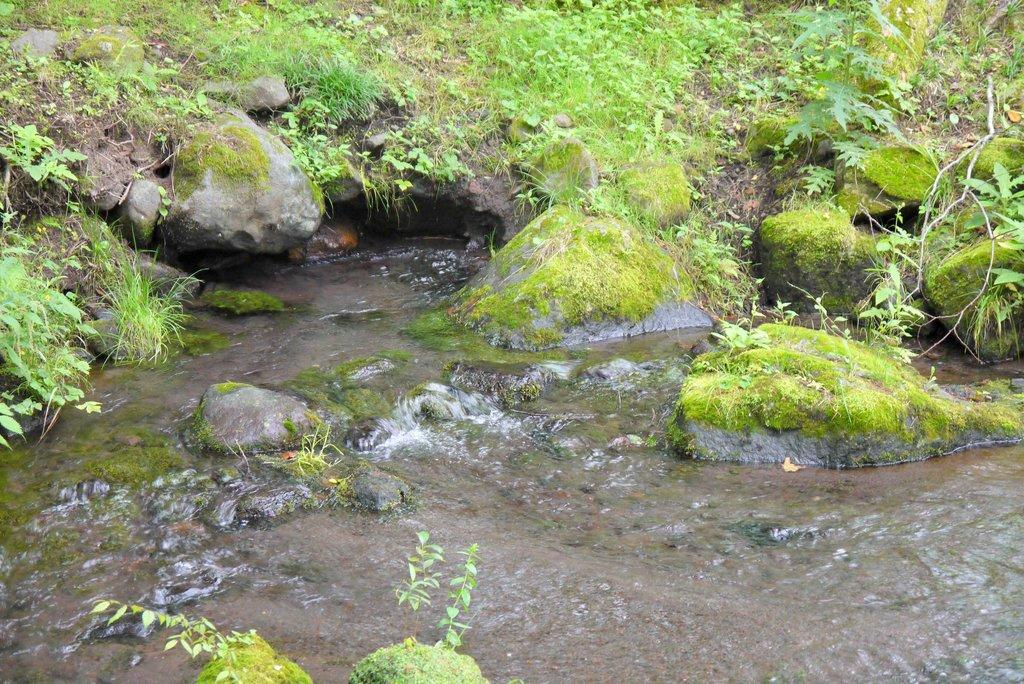What is the primary element in the image? There is water in the image. What can be seen within the water? There are rocks in the water. What type of vegetation is visible in the image? There is grass visible in the image. What type of art is being selected by the women in the image? There are no women or art present in the image; it features water, rocks, and grass. 